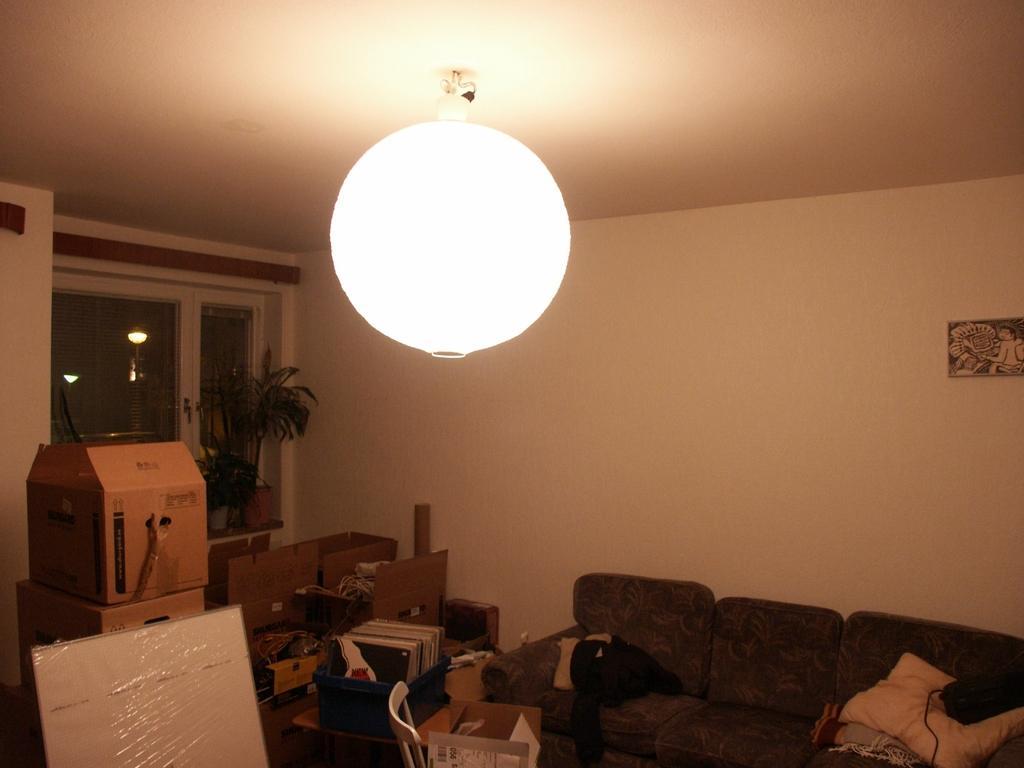In one or two sentences, can you explain what this image depicts? The picture is taken inside the room. In this image there is a sofa on the right side. At the bottom there are cardboard boxes kept on the floor. At the top there is light. On the left side there is a window. At the bottom there is a whiteboard. On the floor there are chairs and boxes. On the sofa there are clothes and a pillow. 